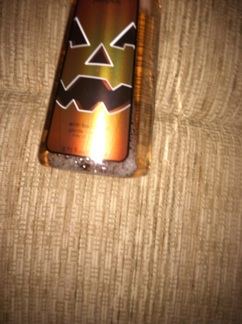Can you tell what brand this might be? It's for Halloween. The brand isn't visible in the image, but based on the festive design, it could be from a company that specializes in seasonal or holiday-themed products. Brands often release limited-edition items like this around Halloween. 